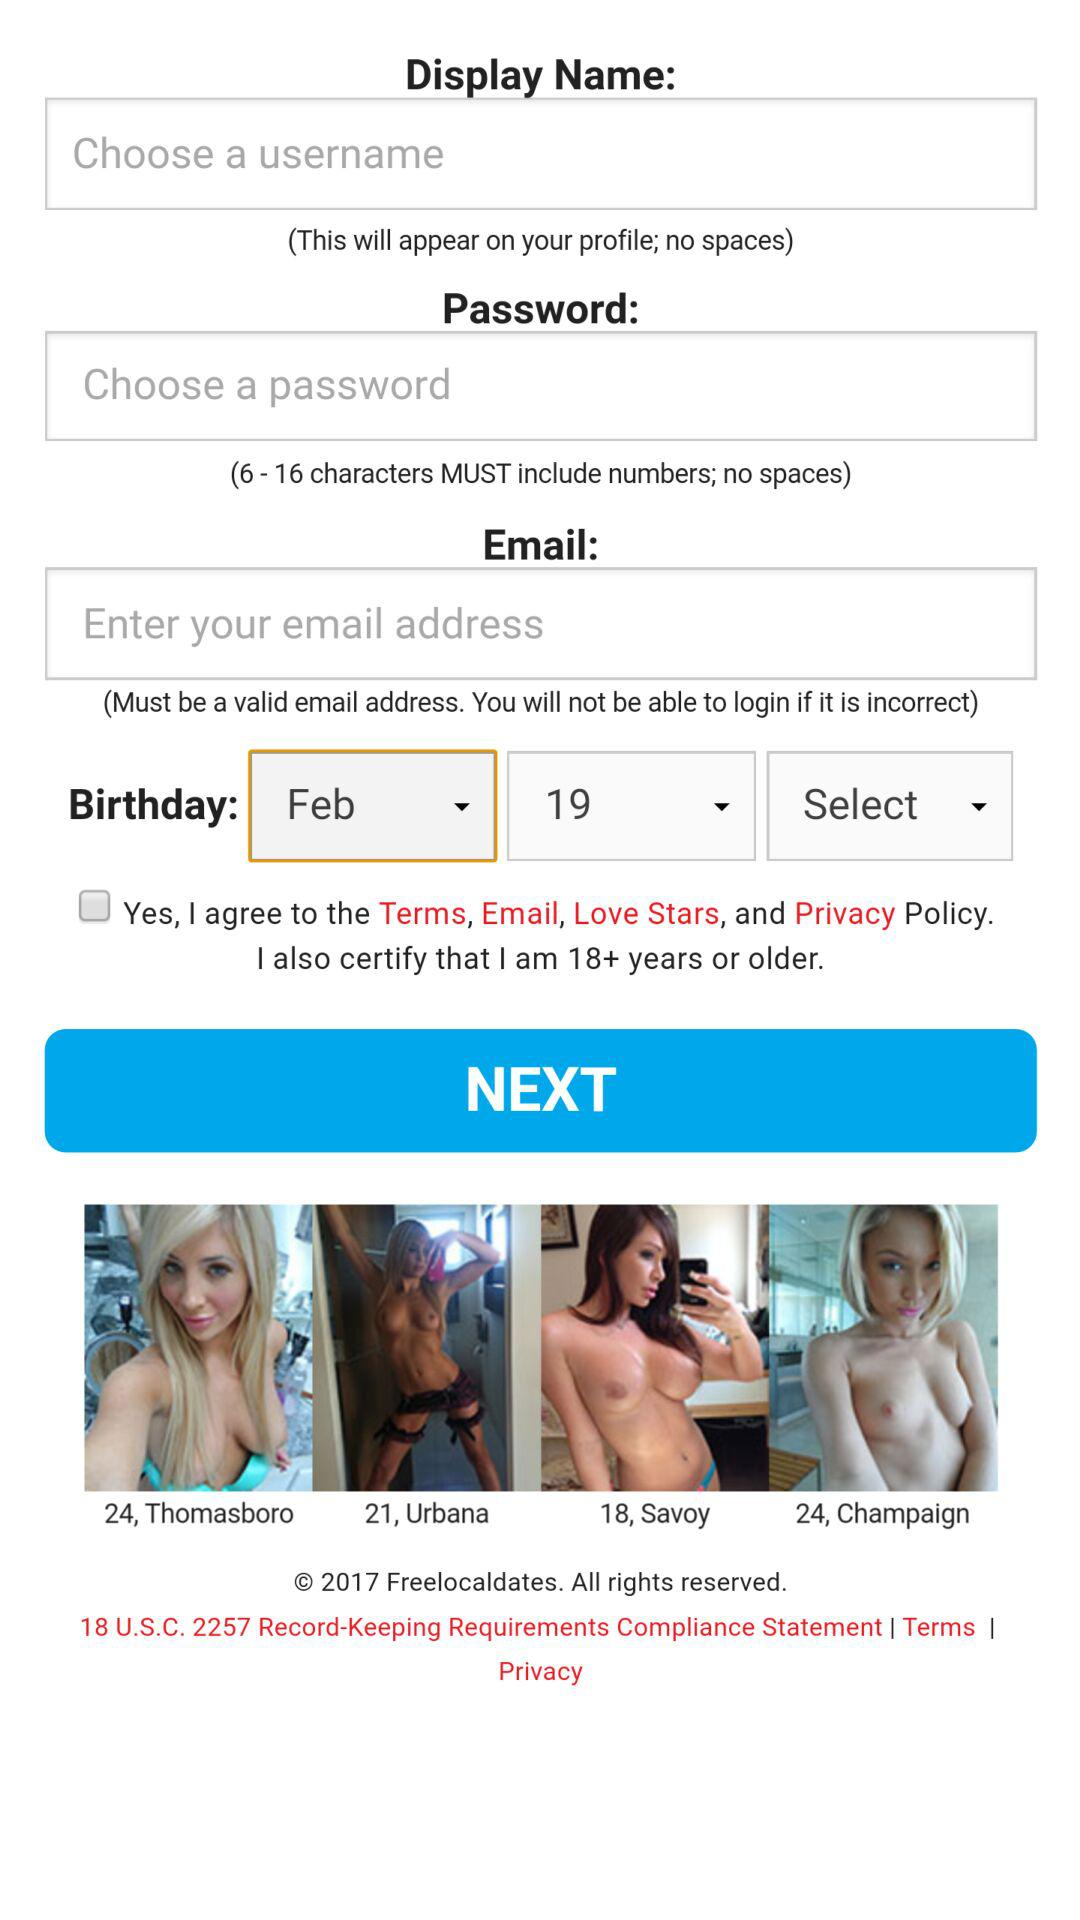How many characters need to be included in the password? The characters that need to be included in the password are from 6 to 16. 